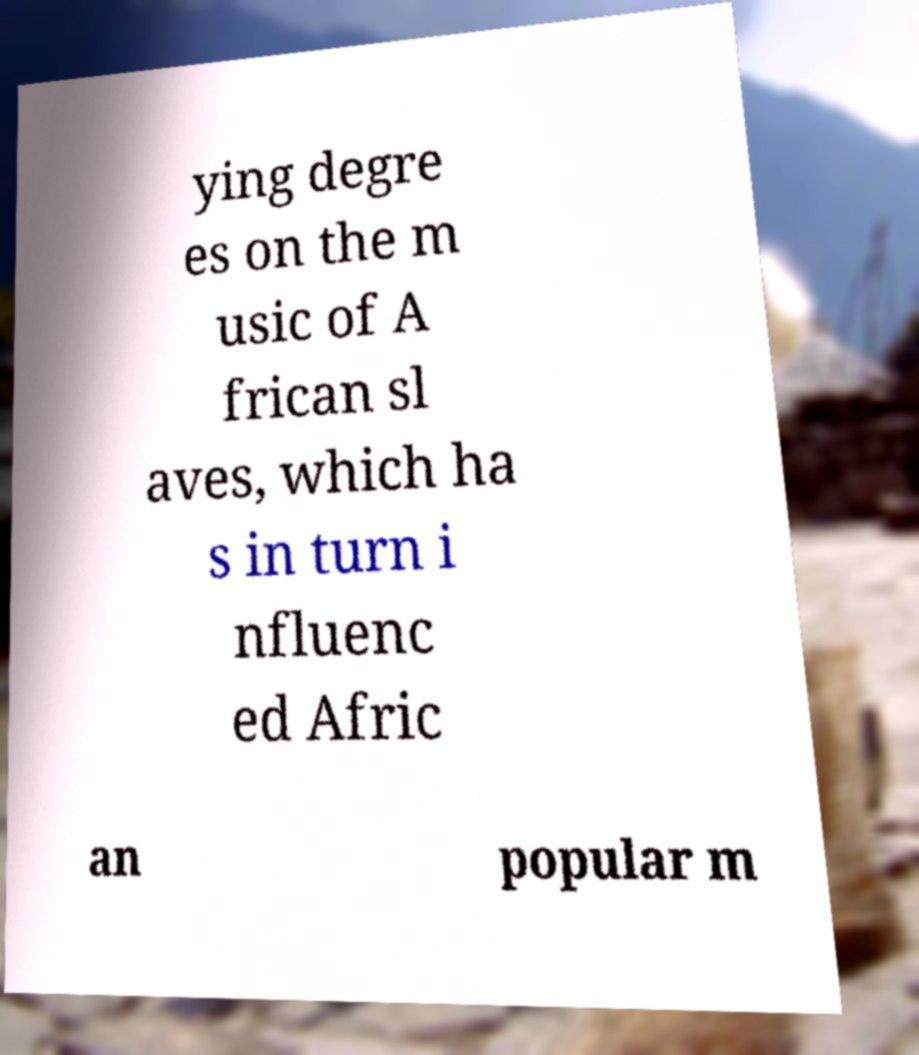There's text embedded in this image that I need extracted. Can you transcribe it verbatim? ying degre es on the m usic of A frican sl aves, which ha s in turn i nfluenc ed Afric an popular m 